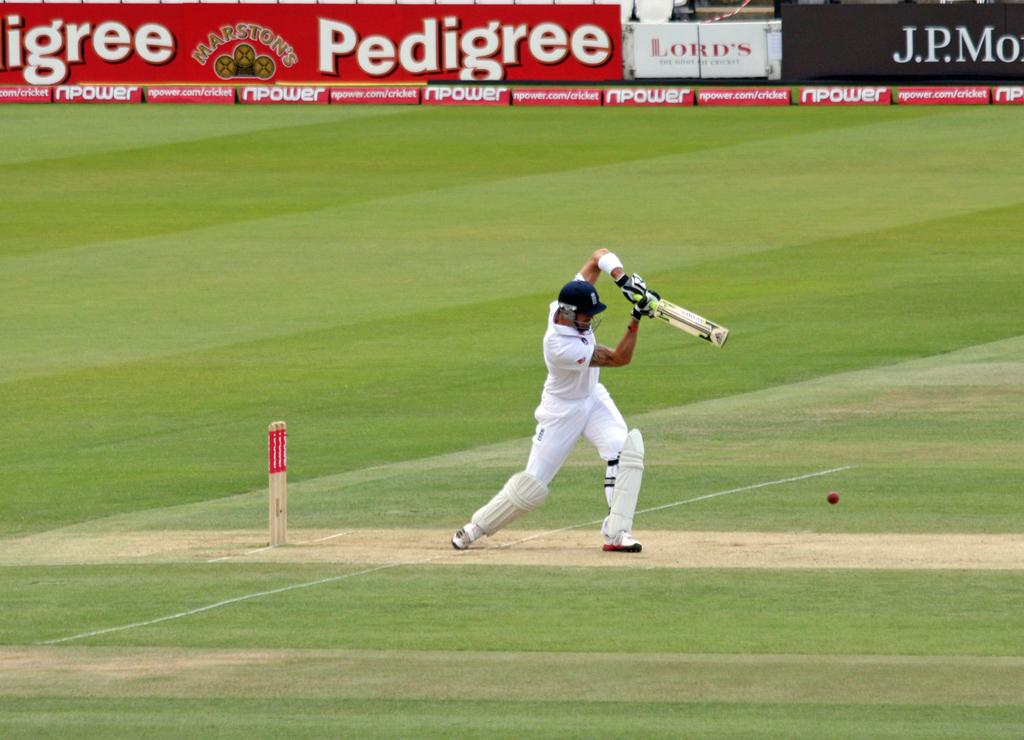<image>
Provide a brief description of the given image. The cricket match advertisers included Pedigree, Lord's, npower, and J.P.Morgan. 